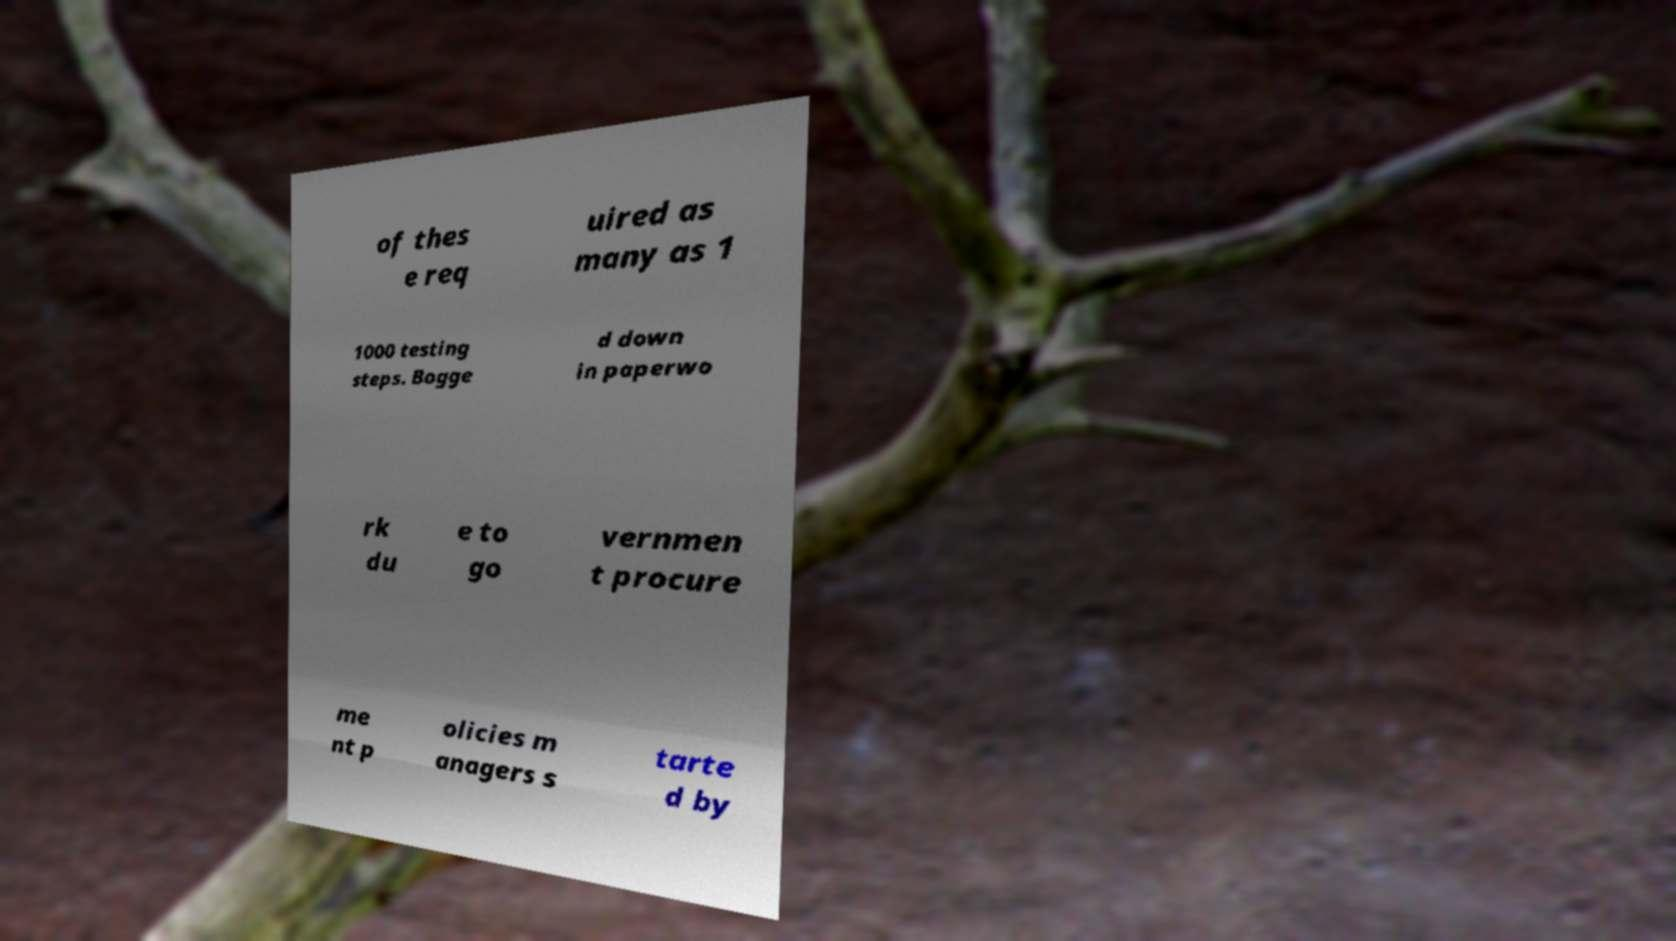For documentation purposes, I need the text within this image transcribed. Could you provide that? of thes e req uired as many as 1 1000 testing steps. Bogge d down in paperwo rk du e to go vernmen t procure me nt p olicies m anagers s tarte d by 